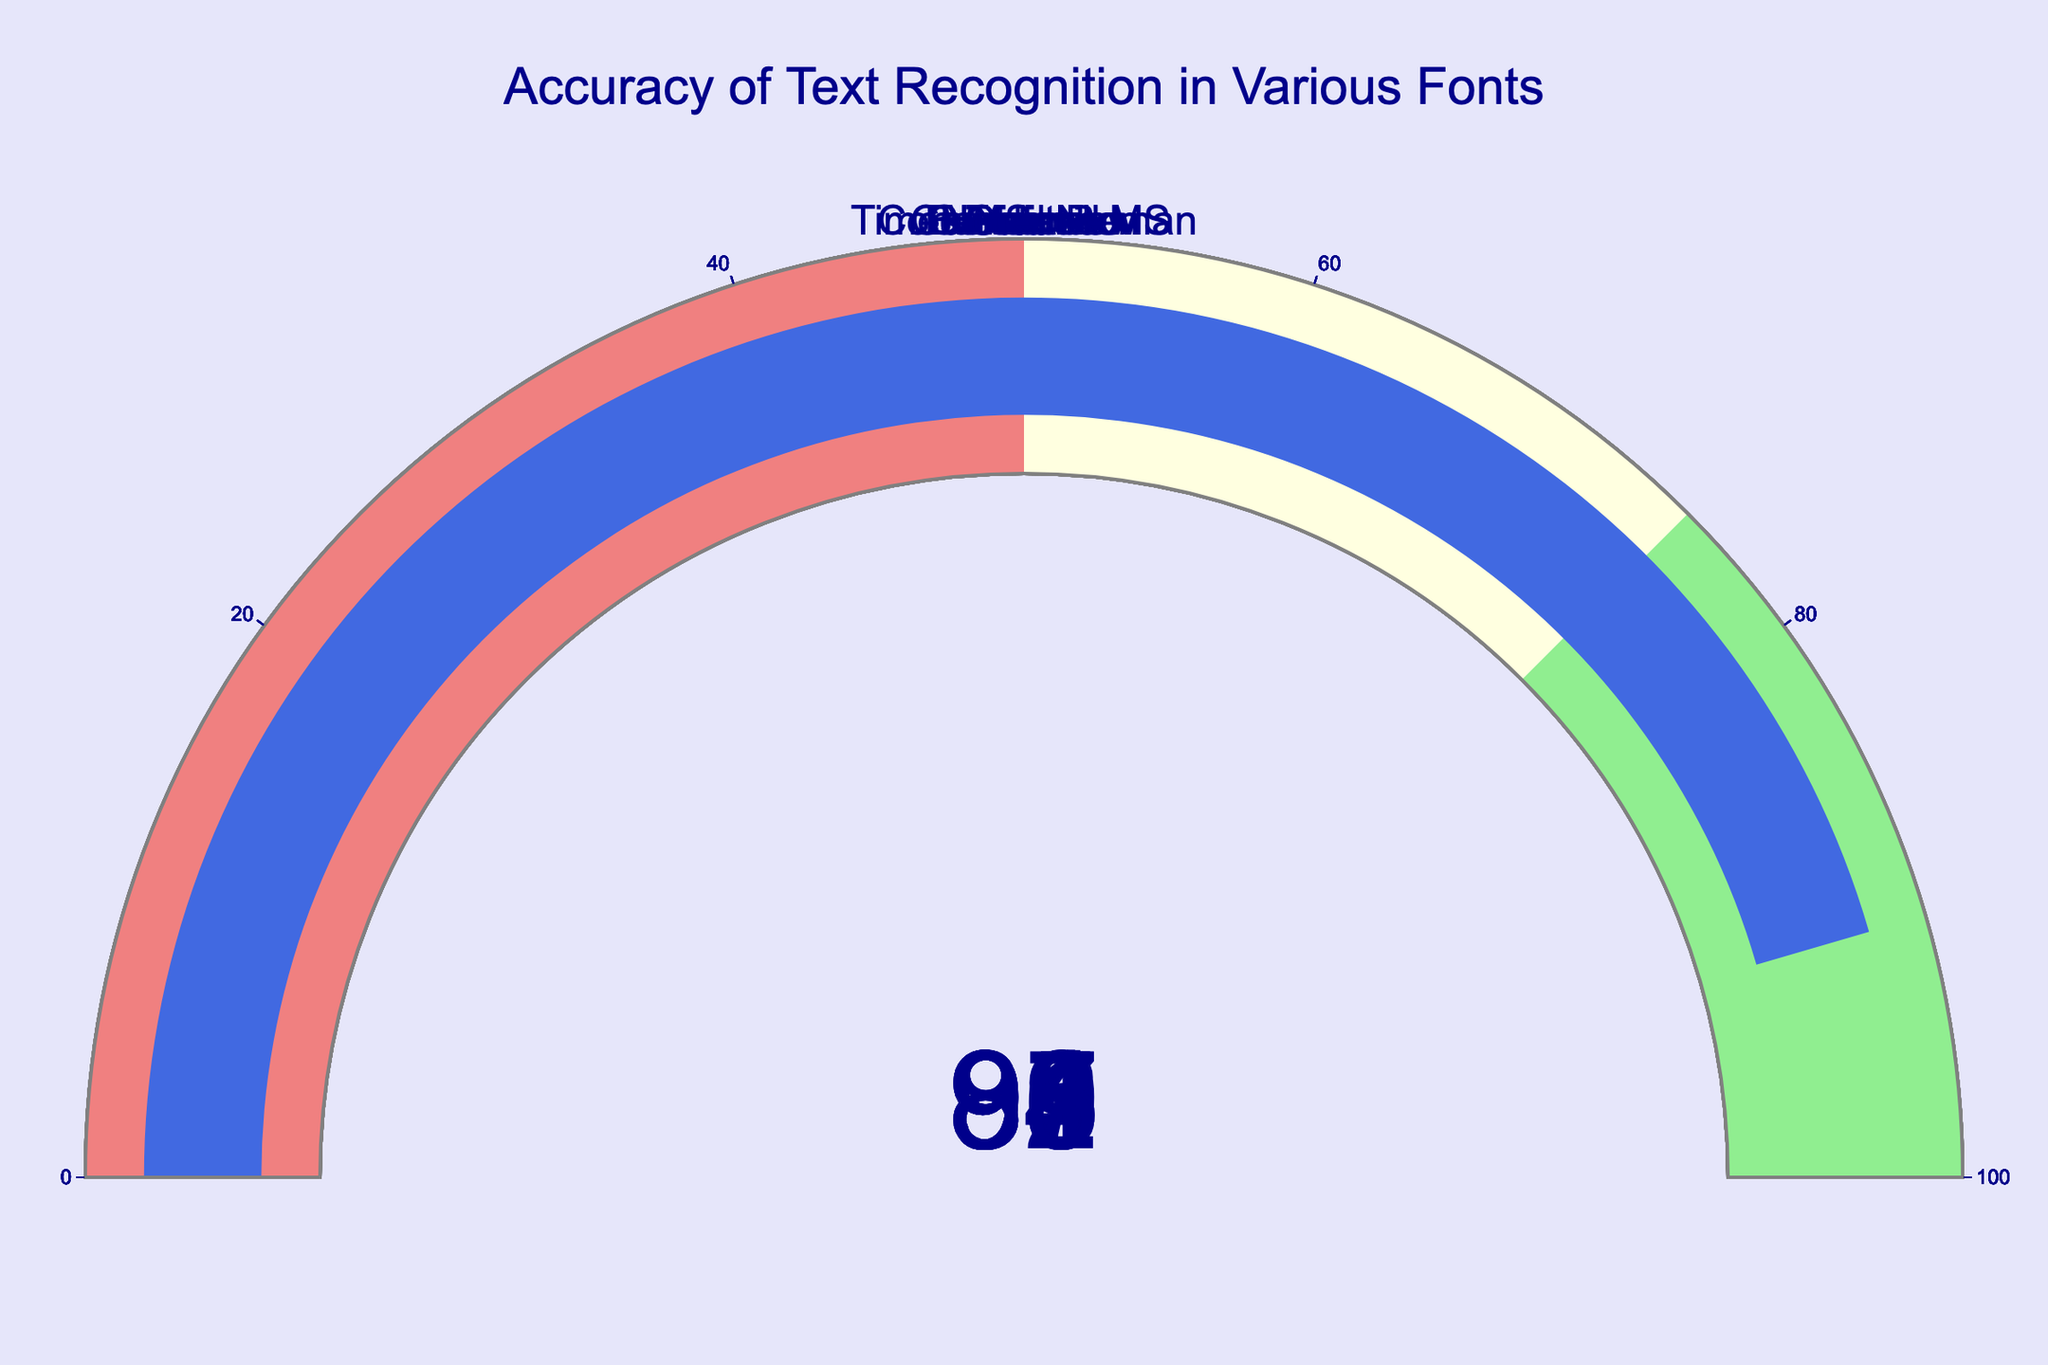What is the accuracy of text recognition for the Arial font? The gauge chart for Arial shows a number, which indicates the accuracy of text recognition for that font.
Answer: 95 How many fonts have an accuracy of text recognition above 90%? Count the number of gauges with values above 90%. These fonts are Arial, Times New Roman, Helvetica, Calibri, Verdana, and Courier New.
Answer: 6 Which font has the lowest accuracy of text recognition? The font with the lowest gauge value will have the lowest accuracy of text recognition. Comic Sans MS has the lowest accuracy.
Answer: Comic Sans MS What is the difference in accuracy between Verdana and Futura? Subtract the accuracy of Futura from that of Verdana. Verdana's accuracy is 96, Futura's is 89.
Answer: 7 Which fonts have an accuracy lower than 90%? Identify the fonts with gauge values below 90%. These fonts are Futura, Garamond, Comic Sans MS, and Baskerville.
Answer: Futura, Garamond, Comic Sans MS, Baskerville What is the average accuracy of text recognition for Arial, Helvetica, and Verdana? Add the accuracies of Arial, Helvetica, and Verdana, then divide by 3. The accuracies are 95, 94, and 96, respectively. (95 + 94 + 96) / 3 = 285 / 3.
Answer: 95 Does Garamond have a higher accuracy than Baskerville? Compare the gauge values of Garamond and Baskerville. Garamond's accuracy is 87, and Baskerville's is 88.
Answer: No What is the median accuracy of all fonts? Arrange the accuracy values in ascending order: 85, 87, 88, 89, 91, 92, 93, 94, 95, 96. The median is the middle value or the average of the two middle values for an even number of data points. Thus, (91 + 92) / 2.
Answer: 91.5 Which two fonts have an accuracy difference of exactly 6%? Compare the difference between accuracies of each pair of fonts. The pairs with a difference of 6% are Helvetica (94) and Calibri (93).
Answer: Helvetica and Calibri 